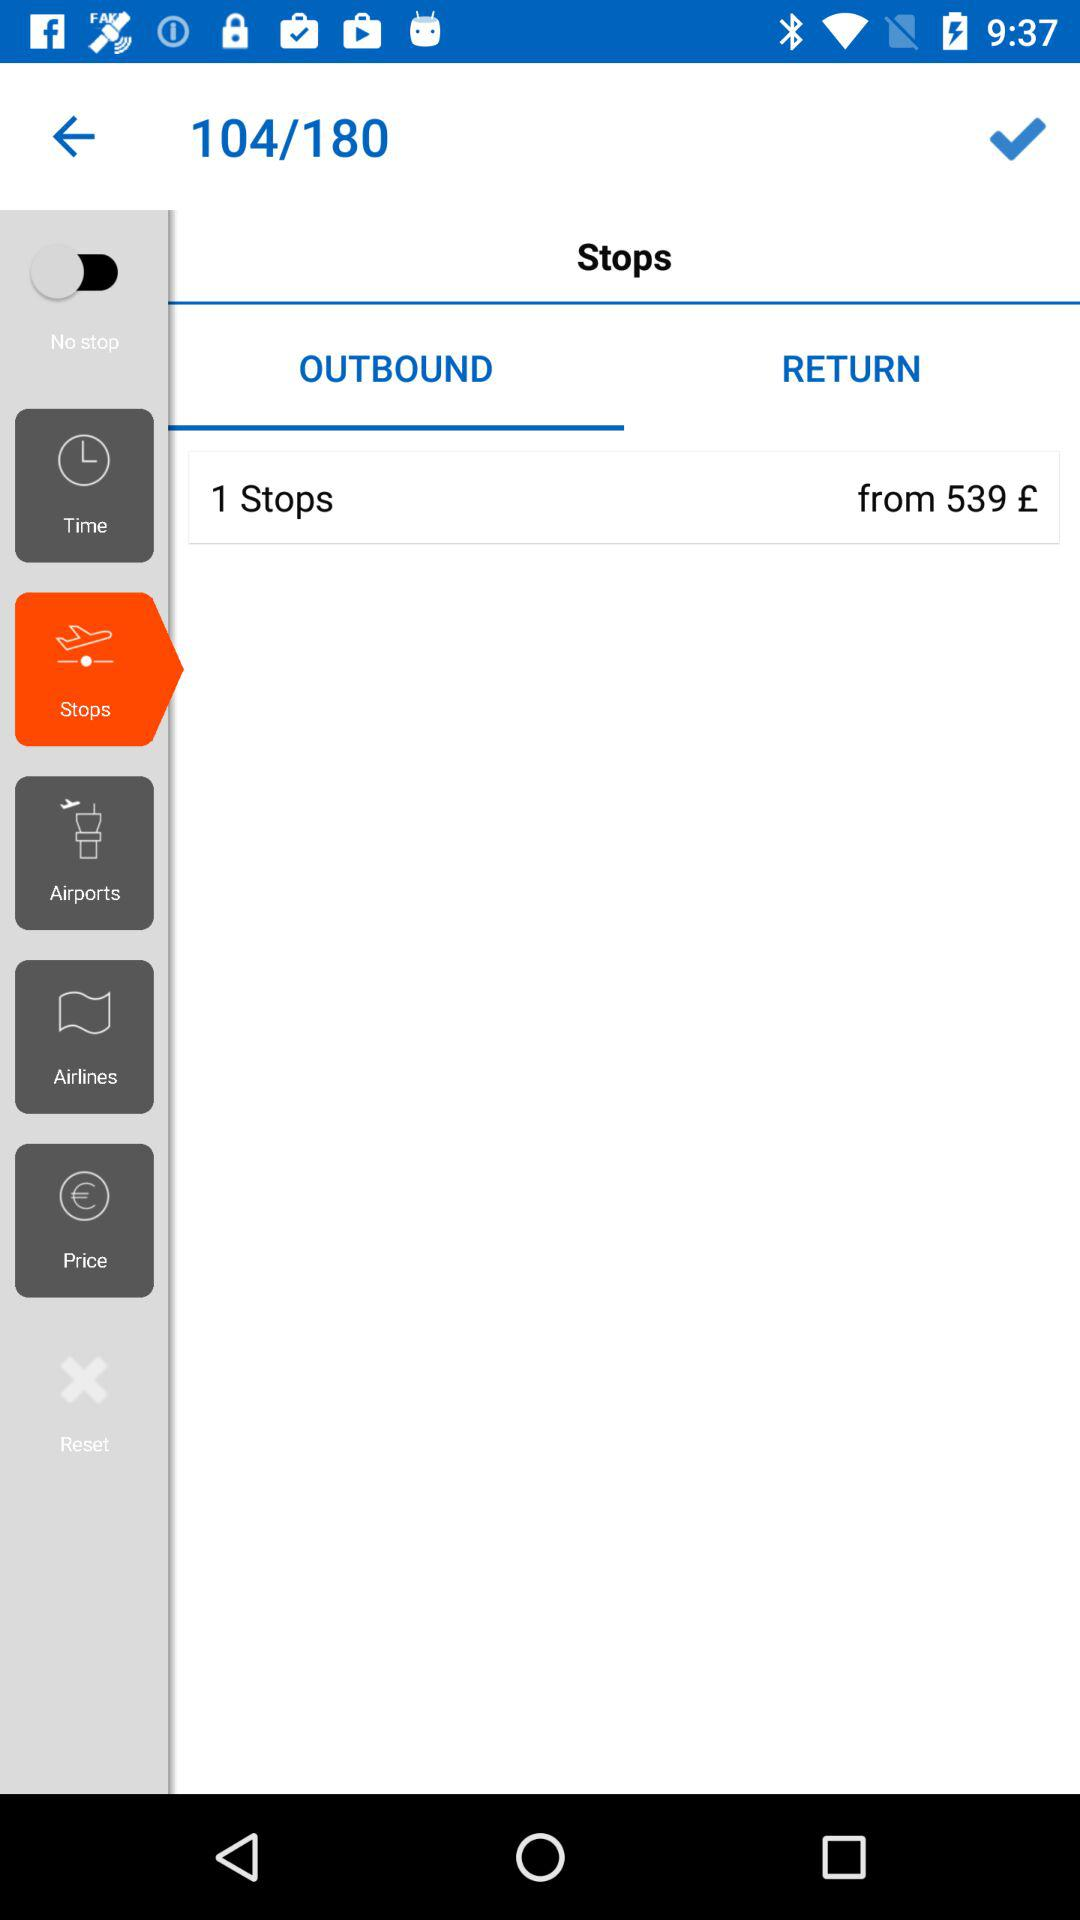What is the currency used for the amount? The currency used for the amount is pounds. 